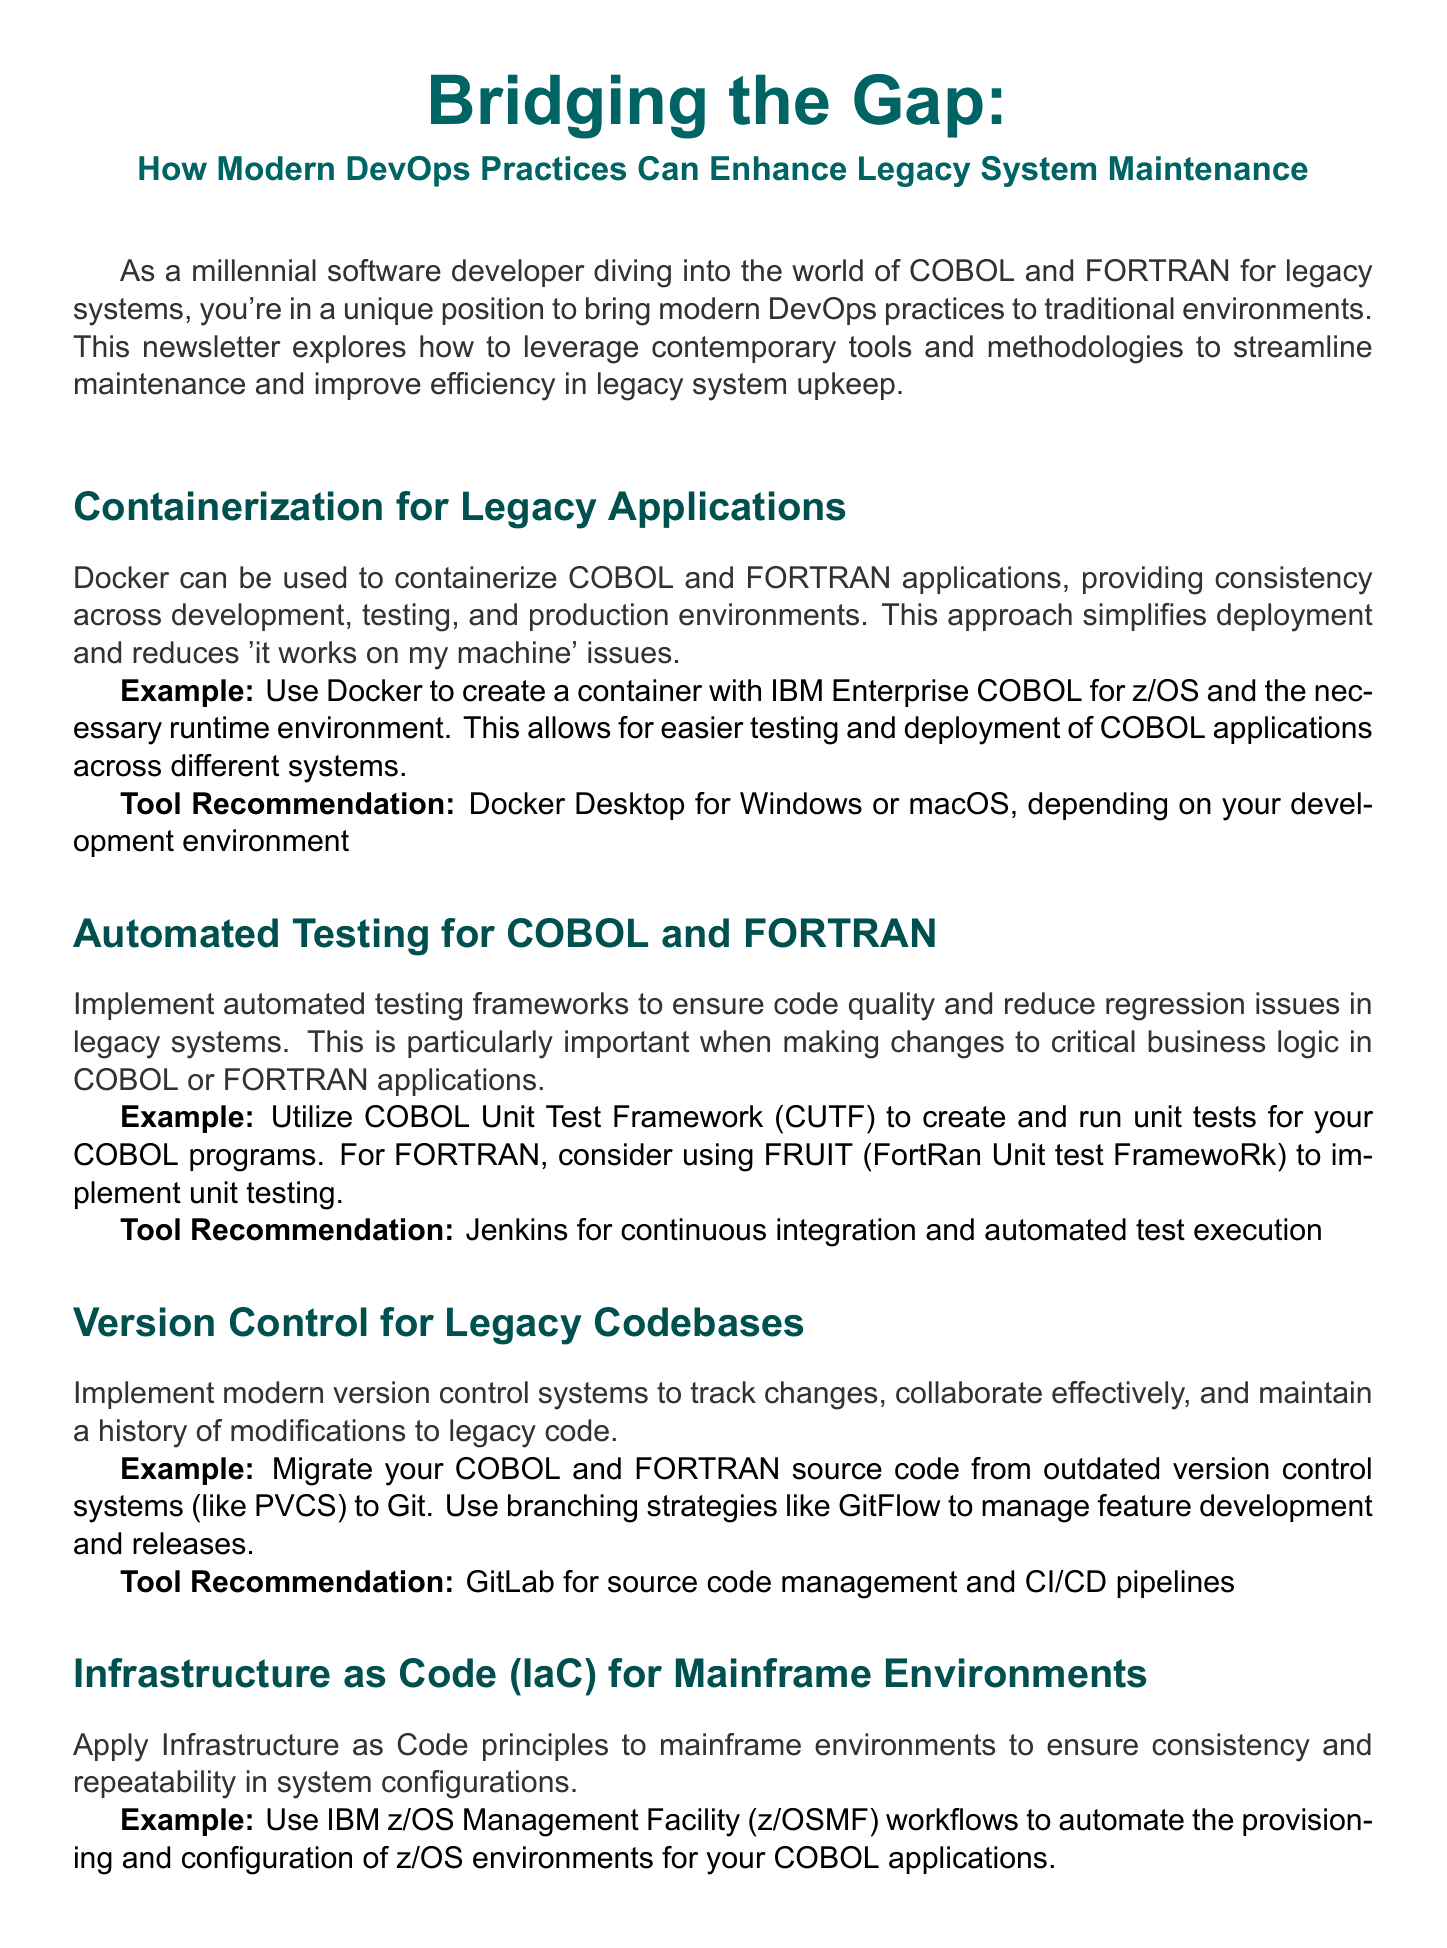What is the newsletter title? The title of the newsletter provides insight into its focus regarding DevOps practices and legacy systems.
Answer: Bridging the Gap: How Modern DevOps Practices Can Enhance Legacy System Maintenance What is the example for containerization? The example illustrates how Docker can be utilized to make COBOL applications more consistent across different systems.
Answer: Use Docker to create a container with IBM Enterprise COBOL for z/OS What tool is recommended for automated testing? The tool recommendation indicates a suitable framework for executing automated tests in legacy code.
Answer: Jenkins What does IaC stand for? This abbreviation summarizes a key methodology discussed in the document for managing infrastructure.
Answer: Infrastructure as Code How should COBOL and FORTRAN code be versioned? This question focuses on the preferred modern version control method discussed for handling legacy code.
Answer: Migrate your COBOL and FORTRAN source code from outdated version control systems to Git What is recommended for monitoring legacy systems? This part of the content focuses on ensuring performance insights into legacy applications.
Answer: Datadog What is the main benefit of using an API-first approach? Understanding this benefit helps illustrate how legacy systems can be integrated with modern applications.
Answer: Easier integration with modern applications and microservices Which automated tool is suggested for mainframe operations? This tool is recommended based on its automation capabilities within mainframe environments.
Answer: Ansible What is the conclusion of the newsletter? This summary helps to encapsulate the overall message about modern practices for legacy systems.
Answer: Enhance the maintenance and evolution of legacy systems 